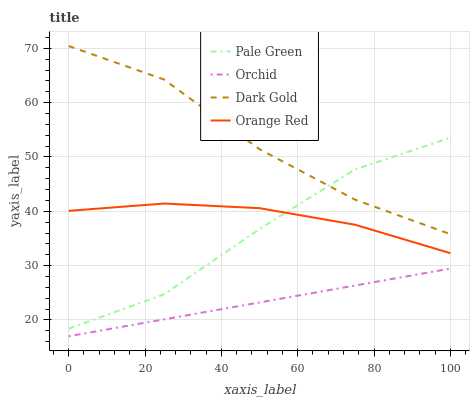Does Orchid have the minimum area under the curve?
Answer yes or no. Yes. Does Dark Gold have the maximum area under the curve?
Answer yes or no. Yes. Does Orange Red have the minimum area under the curve?
Answer yes or no. No. Does Orange Red have the maximum area under the curve?
Answer yes or no. No. Is Orchid the smoothest?
Answer yes or no. Yes. Is Dark Gold the roughest?
Answer yes or no. Yes. Is Orange Red the smoothest?
Answer yes or no. No. Is Orange Red the roughest?
Answer yes or no. No. Does Orchid have the lowest value?
Answer yes or no. Yes. Does Orange Red have the lowest value?
Answer yes or no. No. Does Dark Gold have the highest value?
Answer yes or no. Yes. Does Orange Red have the highest value?
Answer yes or no. No. Is Orchid less than Dark Gold?
Answer yes or no. Yes. Is Pale Green greater than Orchid?
Answer yes or no. Yes. Does Pale Green intersect Dark Gold?
Answer yes or no. Yes. Is Pale Green less than Dark Gold?
Answer yes or no. No. Is Pale Green greater than Dark Gold?
Answer yes or no. No. Does Orchid intersect Dark Gold?
Answer yes or no. No. 